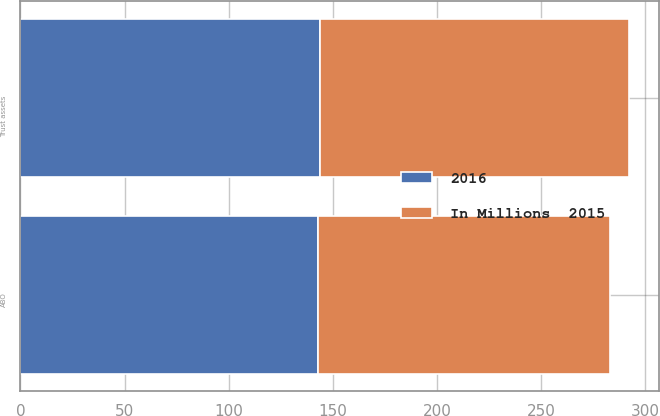Convert chart. <chart><loc_0><loc_0><loc_500><loc_500><stacked_bar_chart><ecel><fcel>Trust assets<fcel>ABO<nl><fcel>2016<fcel>144<fcel>143<nl><fcel>In Millions  2015<fcel>148<fcel>140<nl></chart> 